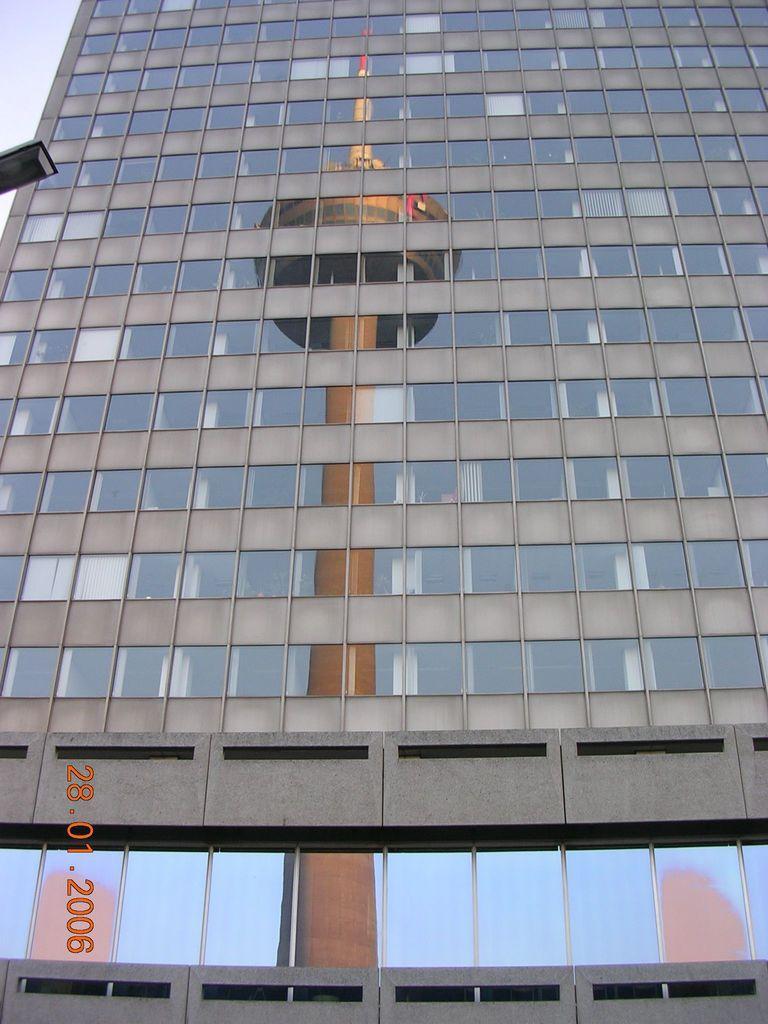Describe this image in one or two sentences. There is a building with glass walls. On the building there is a reflection of a tower. Also there is a watermark in the left bottom corner. 